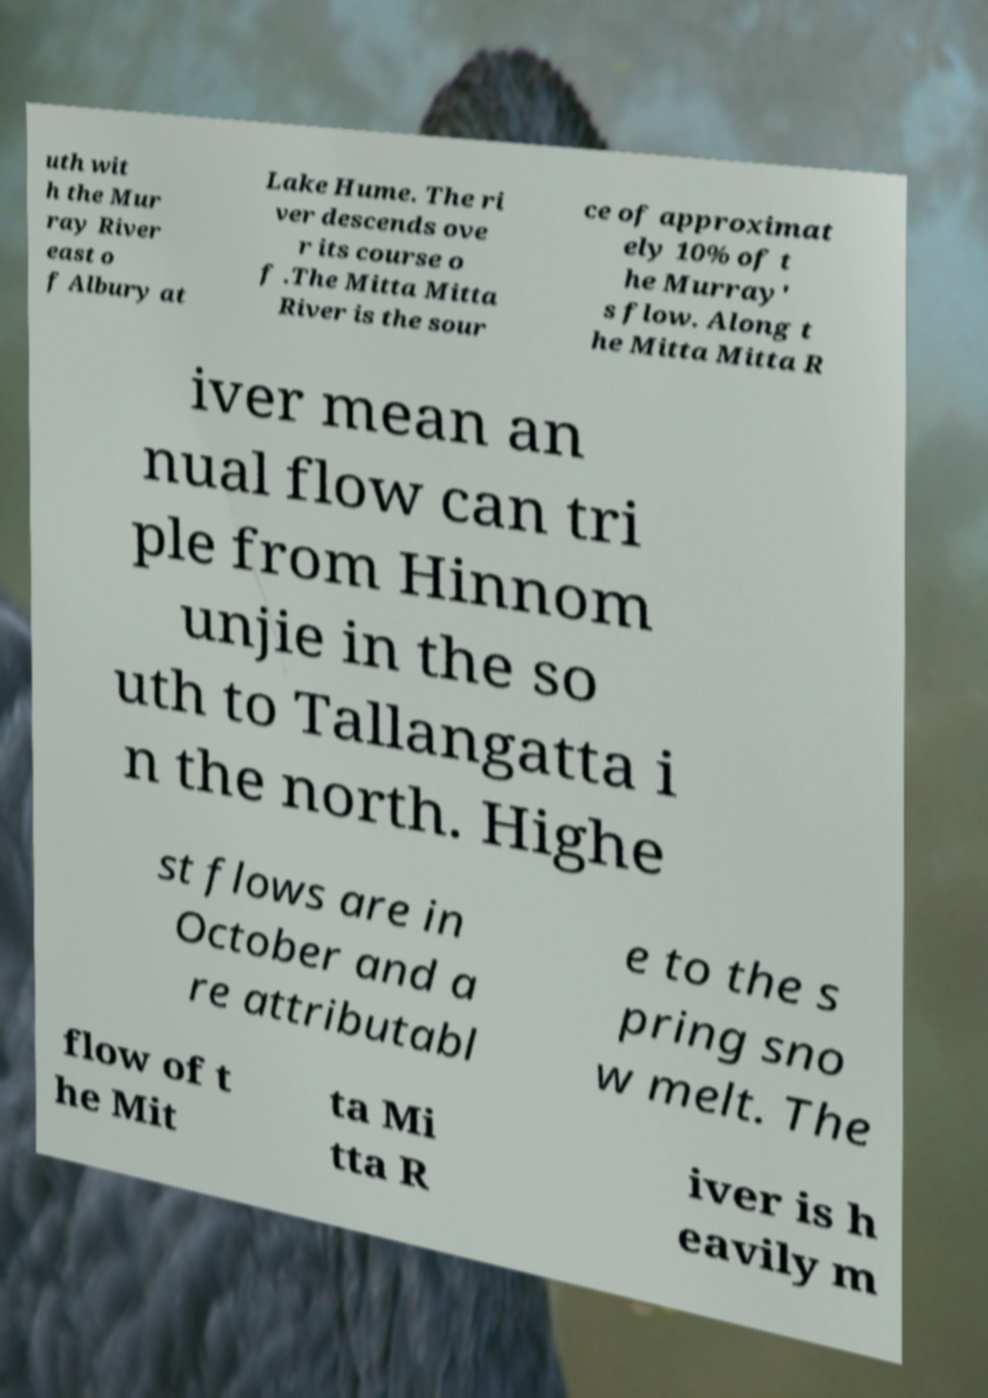Could you extract and type out the text from this image? uth wit h the Mur ray River east o f Albury at Lake Hume. The ri ver descends ove r its course o f .The Mitta Mitta River is the sour ce of approximat ely 10% of t he Murray' s flow. Along t he Mitta Mitta R iver mean an nual flow can tri ple from Hinnom unjie in the so uth to Tallangatta i n the north. Highe st flows are in October and a re attributabl e to the s pring sno w melt. The flow of t he Mit ta Mi tta R iver is h eavily m 